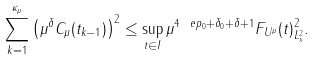Convert formula to latex. <formula><loc_0><loc_0><loc_500><loc_500>\sum _ { k = 1 } ^ { \kappa _ { \mu } } \left ( \mu ^ { \delta } C _ { \mu } ( t _ { k - 1 } ) \right ) ^ { 2 } \leq \sup _ { t \in I } \| \mu ^ { 4 \ e p _ { 0 } + \delta _ { 0 } + \delta + 1 } F _ { U ^ { \mu } } ( t ) \| _ { L _ { x } ^ { 2 } } ^ { 2 } .</formula> 